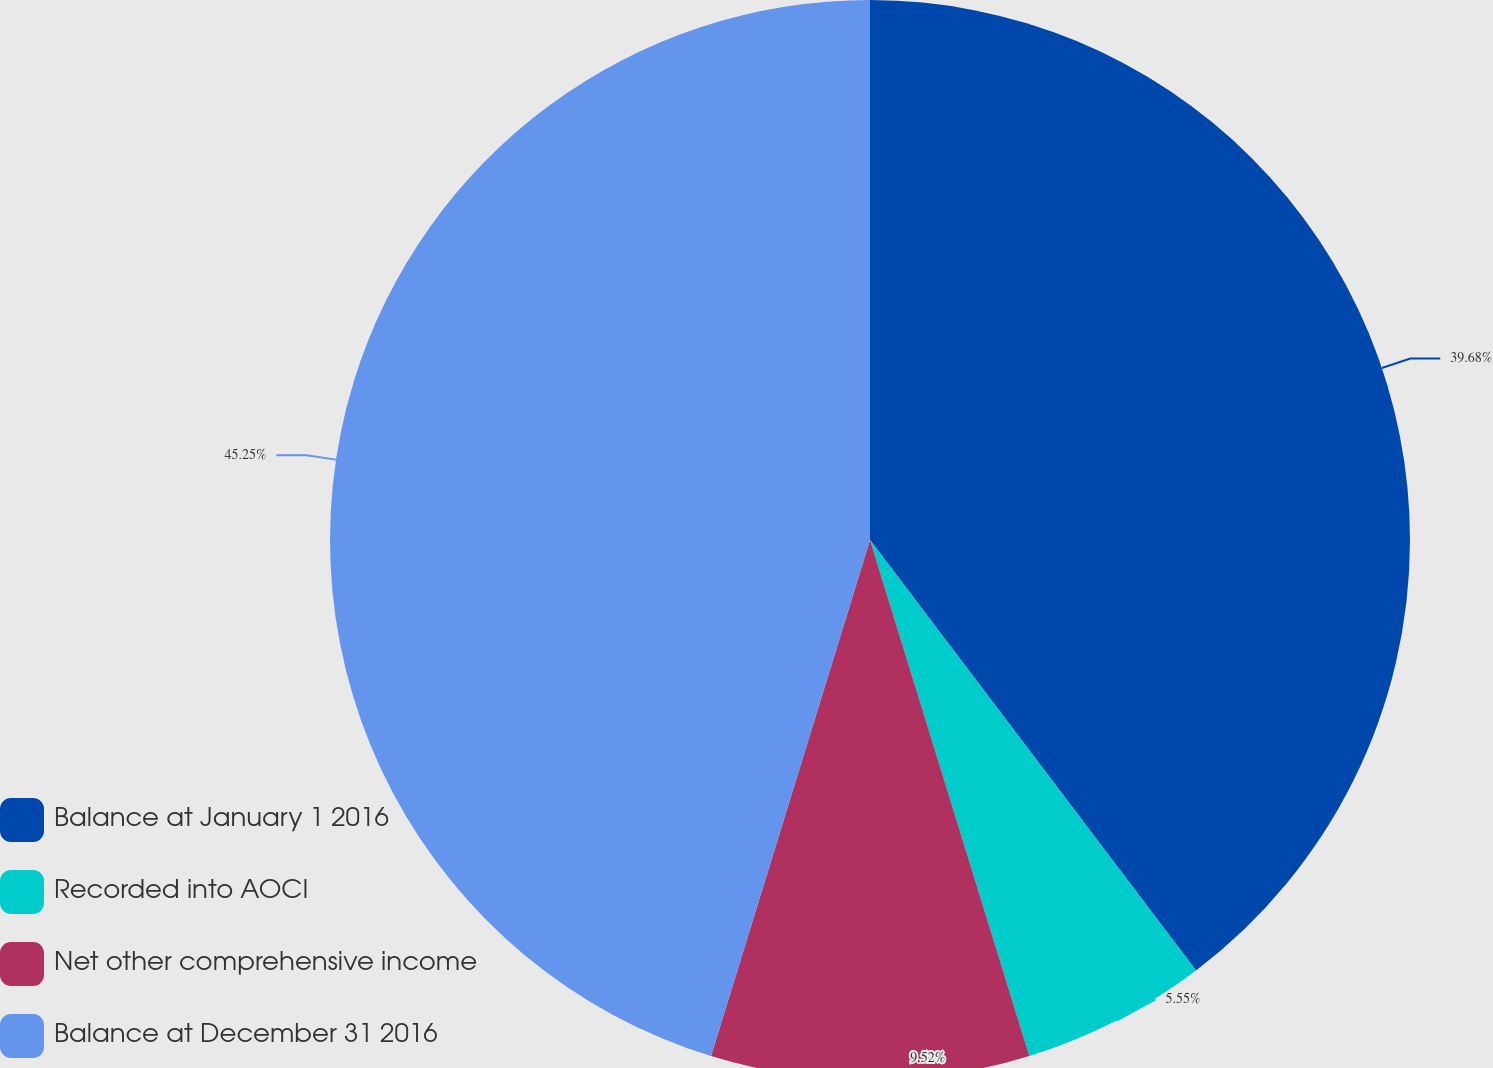Convert chart. <chart><loc_0><loc_0><loc_500><loc_500><pie_chart><fcel>Balance at January 1 2016<fcel>Recorded into AOCI<fcel>Net other comprehensive income<fcel>Balance at December 31 2016<nl><fcel>39.68%<fcel>5.55%<fcel>9.52%<fcel>45.24%<nl></chart> 